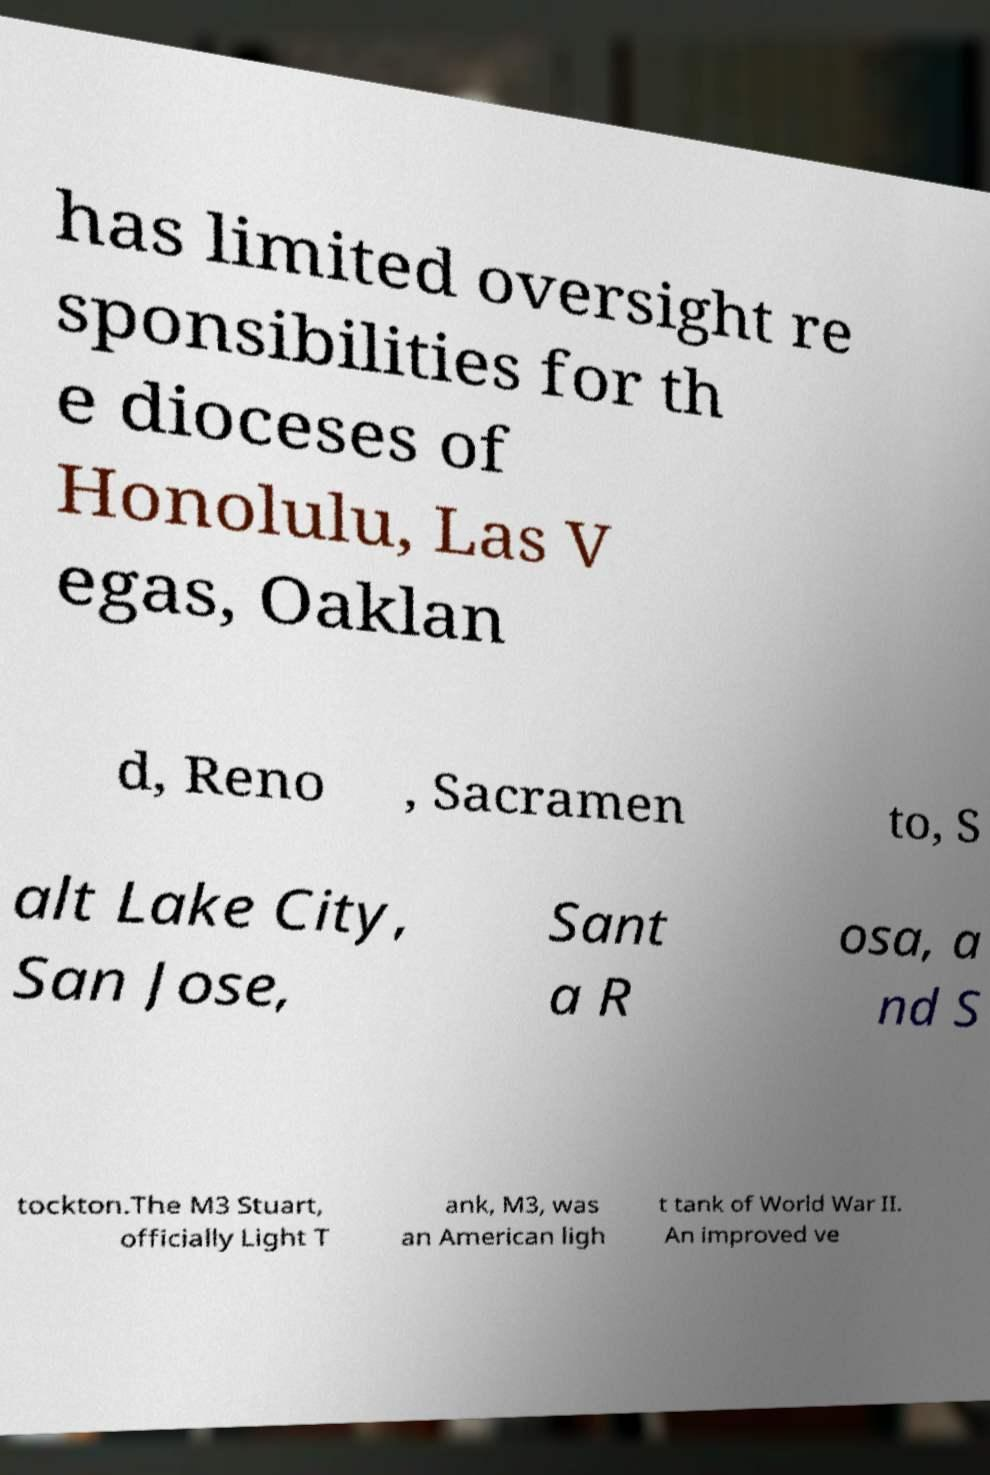For documentation purposes, I need the text within this image transcribed. Could you provide that? has limited oversight re sponsibilities for th e dioceses of Honolulu, Las V egas, Oaklan d, Reno , Sacramen to, S alt Lake City, San Jose, Sant a R osa, a nd S tockton.The M3 Stuart, officially Light T ank, M3, was an American ligh t tank of World War II. An improved ve 